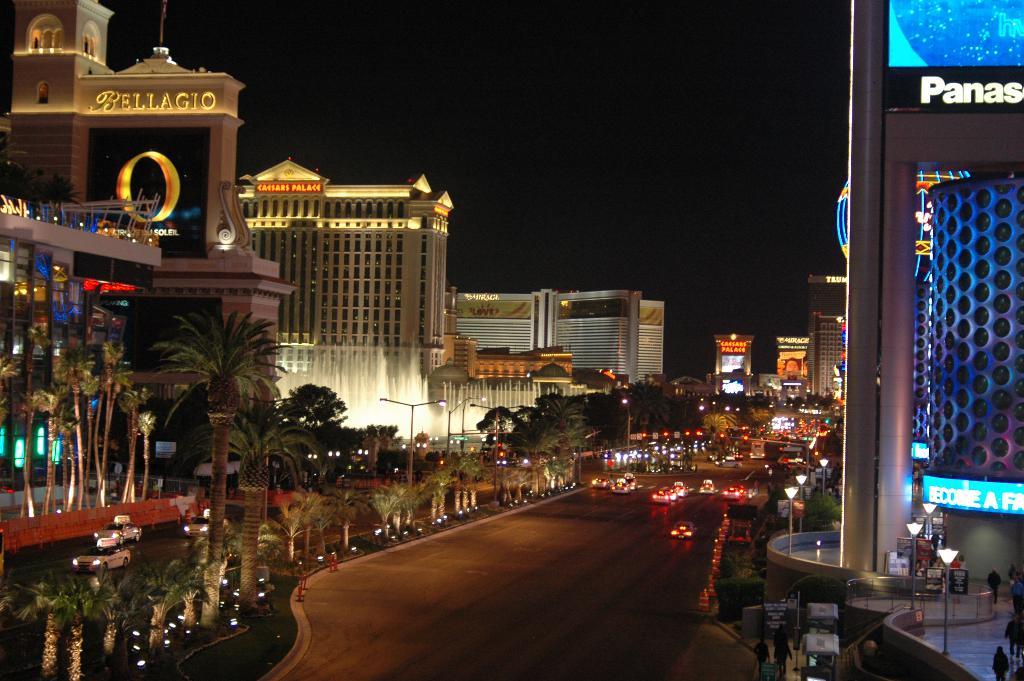What is the name of one of the hotels?
Your answer should be very brief. Bellagio. What letters are at the top right?
Offer a terse response. Panas. 